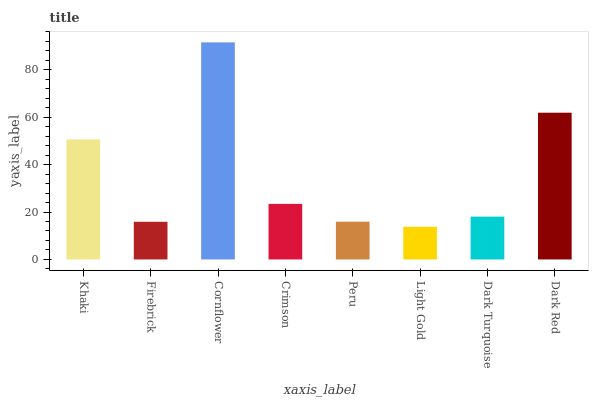Is Light Gold the minimum?
Answer yes or no. Yes. Is Cornflower the maximum?
Answer yes or no. Yes. Is Firebrick the minimum?
Answer yes or no. No. Is Firebrick the maximum?
Answer yes or no. No. Is Khaki greater than Firebrick?
Answer yes or no. Yes. Is Firebrick less than Khaki?
Answer yes or no. Yes. Is Firebrick greater than Khaki?
Answer yes or no. No. Is Khaki less than Firebrick?
Answer yes or no. No. Is Crimson the high median?
Answer yes or no. Yes. Is Dark Turquoise the low median?
Answer yes or no. Yes. Is Dark Red the high median?
Answer yes or no. No. Is Dark Red the low median?
Answer yes or no. No. 